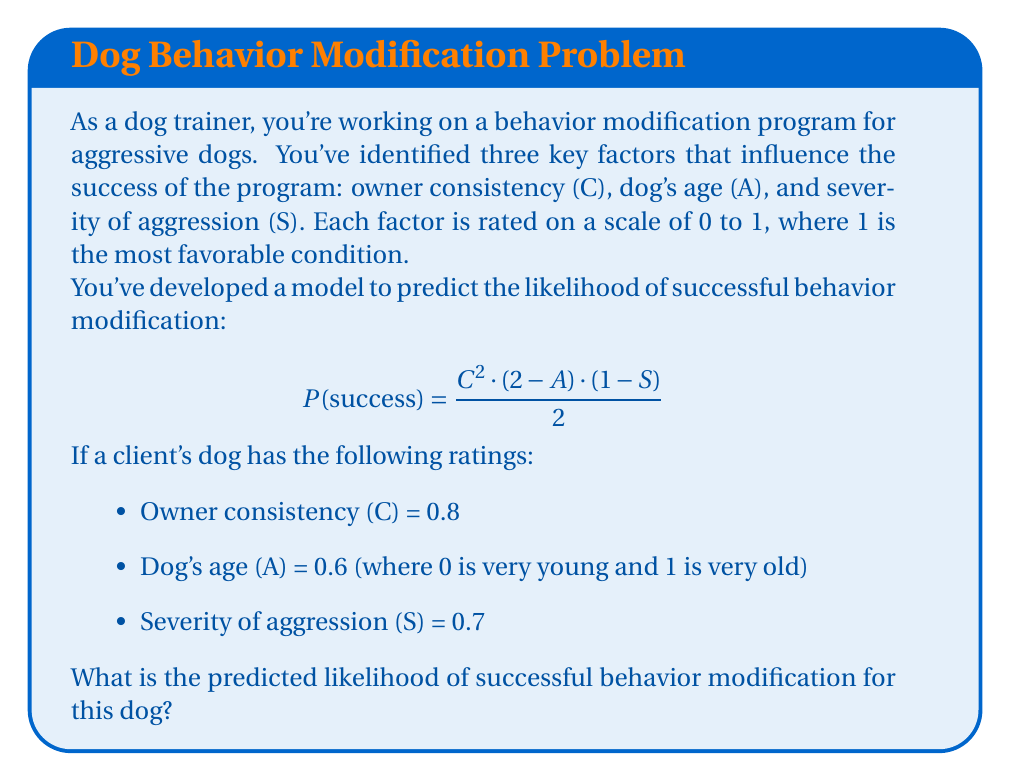What is the answer to this math problem? Let's approach this step-by-step:

1) We're given the formula for the likelihood of success:
   $$P(success) = \frac{C^2 \cdot (2-A) \cdot (1-S)}{2}$$

2) We're also given the values for each variable:
   C = 0.8
   A = 0.6
   S = 0.7

3) Let's substitute these values into the formula:
   $$P(success) = \frac{(0.8)^2 \cdot (2-0.6) \cdot (1-0.7)}{2}$$

4) Now, let's solve each part of the equation:
   - $C^2 = (0.8)^2 = 0.64$
   - $(2-A) = (2-0.6) = 1.4$
   - $(1-S) = (1-0.7) = 0.3$

5) Substituting these back into the equation:
   $$P(success) = \frac{0.64 \cdot 1.4 \cdot 0.3}{2}$$

6) Multiply the numerator:
   $$P(success) = \frac{0.2688}{2}$$

7) Divide:
   $$P(success) = 0.1344$$

8) This can be expressed as a percentage:
   0.1344 * 100 = 13.44%

Therefore, the predicted likelihood of successful behavior modification for this dog is approximately 13.44%.
Answer: 13.44% 